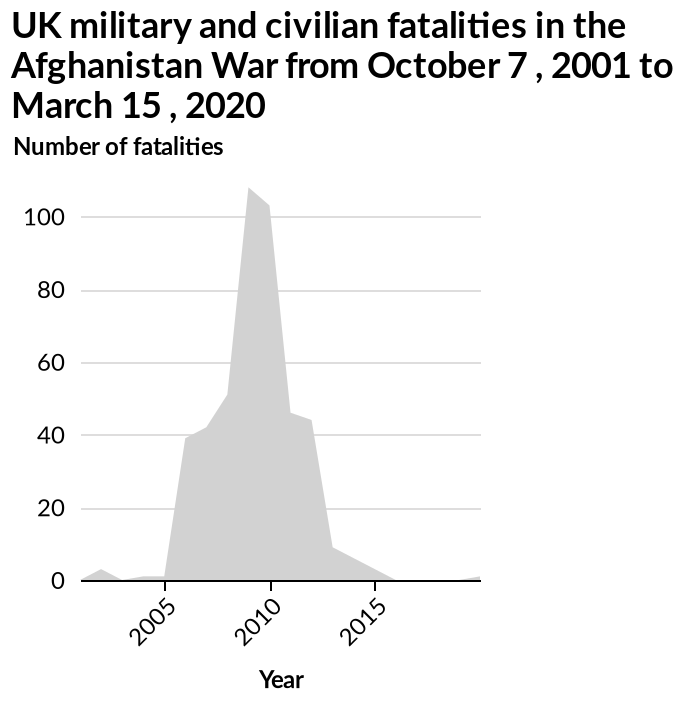<image>
When did fatalities reach their peak?  Fatalities reached their peak in 2008/2009. please enumerates aspects of the construction of the chart This is a area graph titled UK military and civilian fatalities in the Afghanistan War from October 7 , 2001 to March 15 , 2020. Year is shown along a linear scale with a minimum of 2005 and a maximum of 2015 along the x-axis. Number of fatalities is shown along a linear scale with a minimum of 0 and a maximum of 100 on the y-axis. 